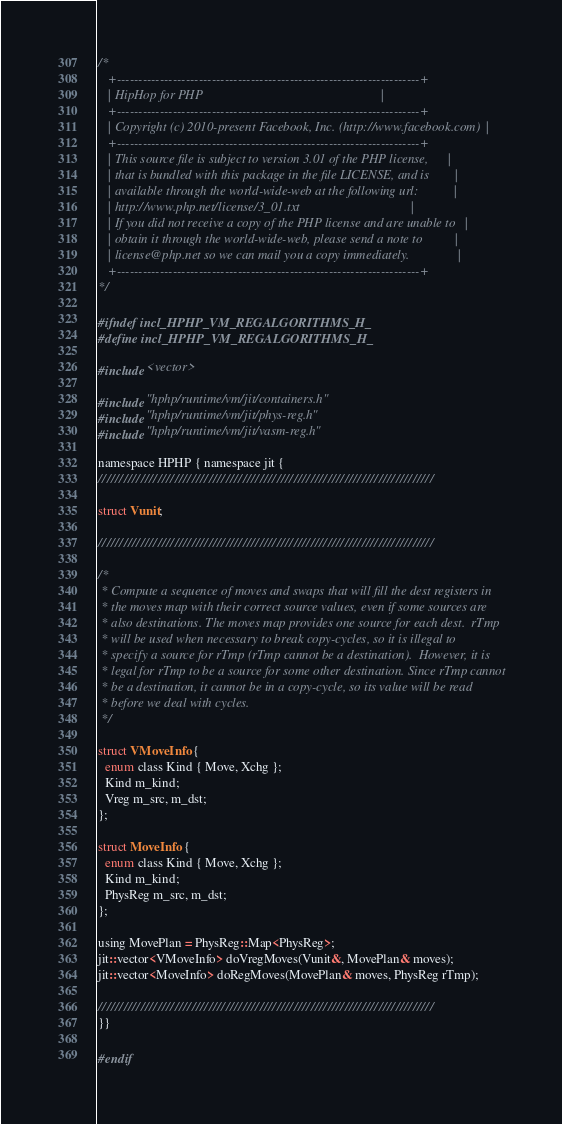Convert code to text. <code><loc_0><loc_0><loc_500><loc_500><_C_>/*
   +----------------------------------------------------------------------+
   | HipHop for PHP                                                       |
   +----------------------------------------------------------------------+
   | Copyright (c) 2010-present Facebook, Inc. (http://www.facebook.com)  |
   +----------------------------------------------------------------------+
   | This source file is subject to version 3.01 of the PHP license,      |
   | that is bundled with this package in the file LICENSE, and is        |
   | available through the world-wide-web at the following url:           |
   | http://www.php.net/license/3_01.txt                                  |
   | If you did not receive a copy of the PHP license and are unable to   |
   | obtain it through the world-wide-web, please send a note to          |
   | license@php.net so we can mail you a copy immediately.               |
   +----------------------------------------------------------------------+
*/

#ifndef incl_HPHP_VM_REGALGORITHMS_H_
#define incl_HPHP_VM_REGALGORITHMS_H_

#include <vector>

#include "hphp/runtime/vm/jit/containers.h"
#include "hphp/runtime/vm/jit/phys-reg.h"
#include "hphp/runtime/vm/jit/vasm-reg.h"

namespace HPHP { namespace jit {
///////////////////////////////////////////////////////////////////////////////

struct Vunit;

///////////////////////////////////////////////////////////////////////////////

/*
 * Compute a sequence of moves and swaps that will fill the dest registers in
 * the moves map with their correct source values, even if some sources are
 * also destinations. The moves map provides one source for each dest.  rTmp
 * will be used when necessary to break copy-cycles, so it is illegal to
 * specify a source for rTmp (rTmp cannot be a destination).  However, it is
 * legal for rTmp to be a source for some other destination. Since rTmp cannot
 * be a destination, it cannot be in a copy-cycle, so its value will be read
 * before we deal with cycles.
 */

struct VMoveInfo {
  enum class Kind { Move, Xchg };
  Kind m_kind;
  Vreg m_src, m_dst;
};

struct MoveInfo {
  enum class Kind { Move, Xchg };
  Kind m_kind;
  PhysReg m_src, m_dst;
};

using MovePlan = PhysReg::Map<PhysReg>;
jit::vector<VMoveInfo> doVregMoves(Vunit&, MovePlan& moves);
jit::vector<MoveInfo> doRegMoves(MovePlan& moves, PhysReg rTmp);

///////////////////////////////////////////////////////////////////////////////
}}

#endif
</code> 